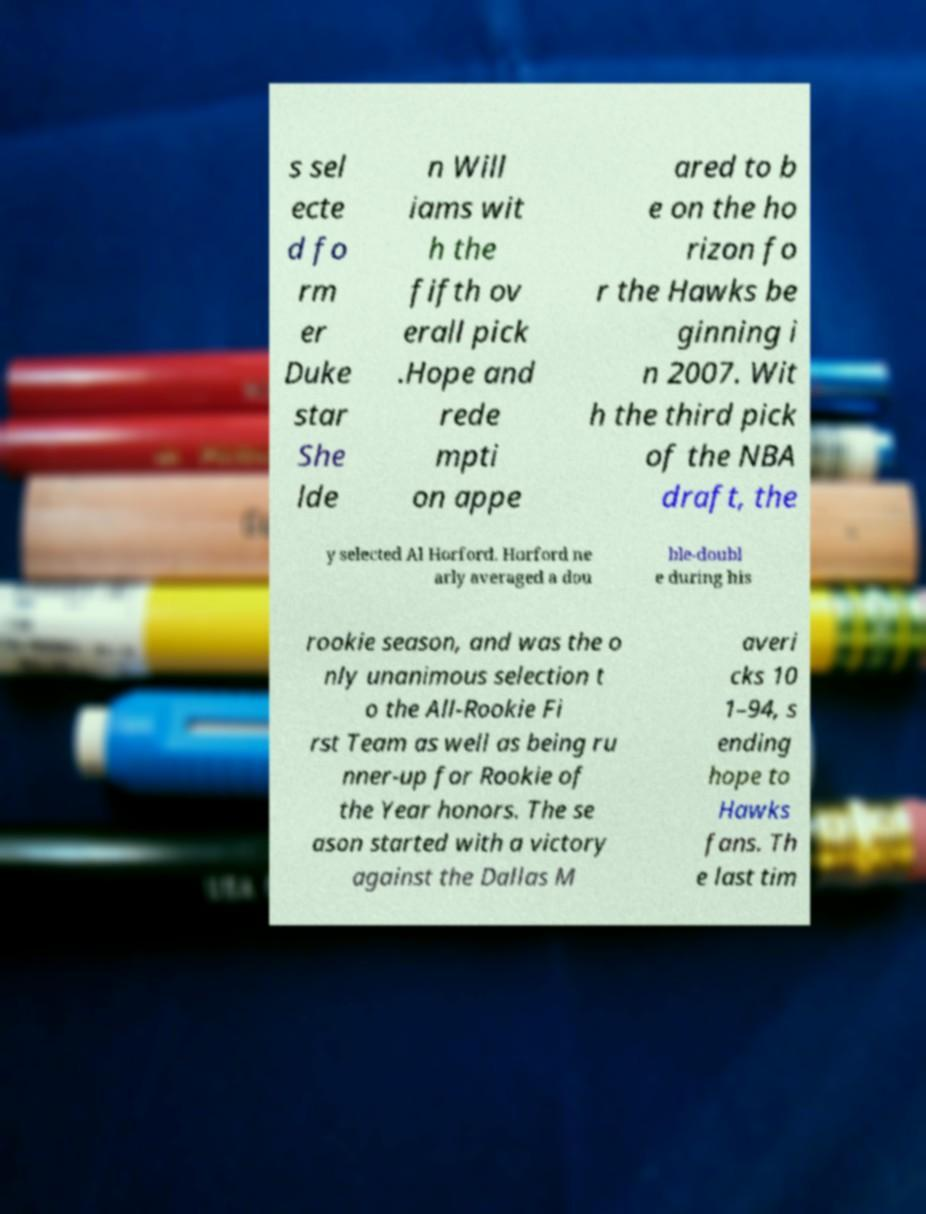Please identify and transcribe the text found in this image. s sel ecte d fo rm er Duke star She lde n Will iams wit h the fifth ov erall pick .Hope and rede mpti on appe ared to b e on the ho rizon fo r the Hawks be ginning i n 2007. Wit h the third pick of the NBA draft, the y selected Al Horford. Horford ne arly averaged a dou ble-doubl e during his rookie season, and was the o nly unanimous selection t o the All-Rookie Fi rst Team as well as being ru nner-up for Rookie of the Year honors. The se ason started with a victory against the Dallas M averi cks 10 1–94, s ending hope to Hawks fans. Th e last tim 